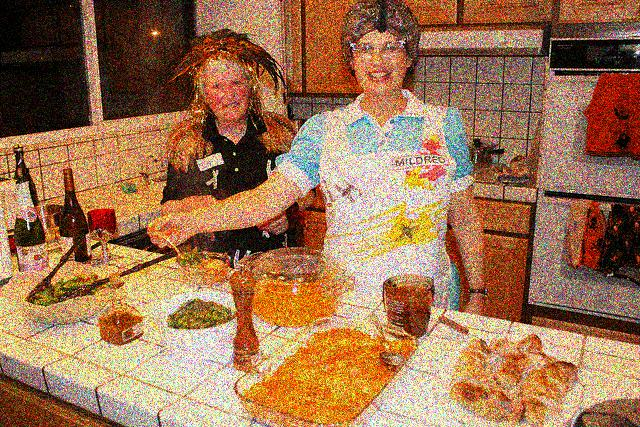Can you describe the activities the women are involved in? The two women appear to be engaged in a cooking activity, with various food items and utensils spread across the counter. One woman seems to be stirring a bowl, possibly preparing a recipe, while the other appears to be interacting with her, perhaps discussing the cooking process or sharing a light-hearted moment. 